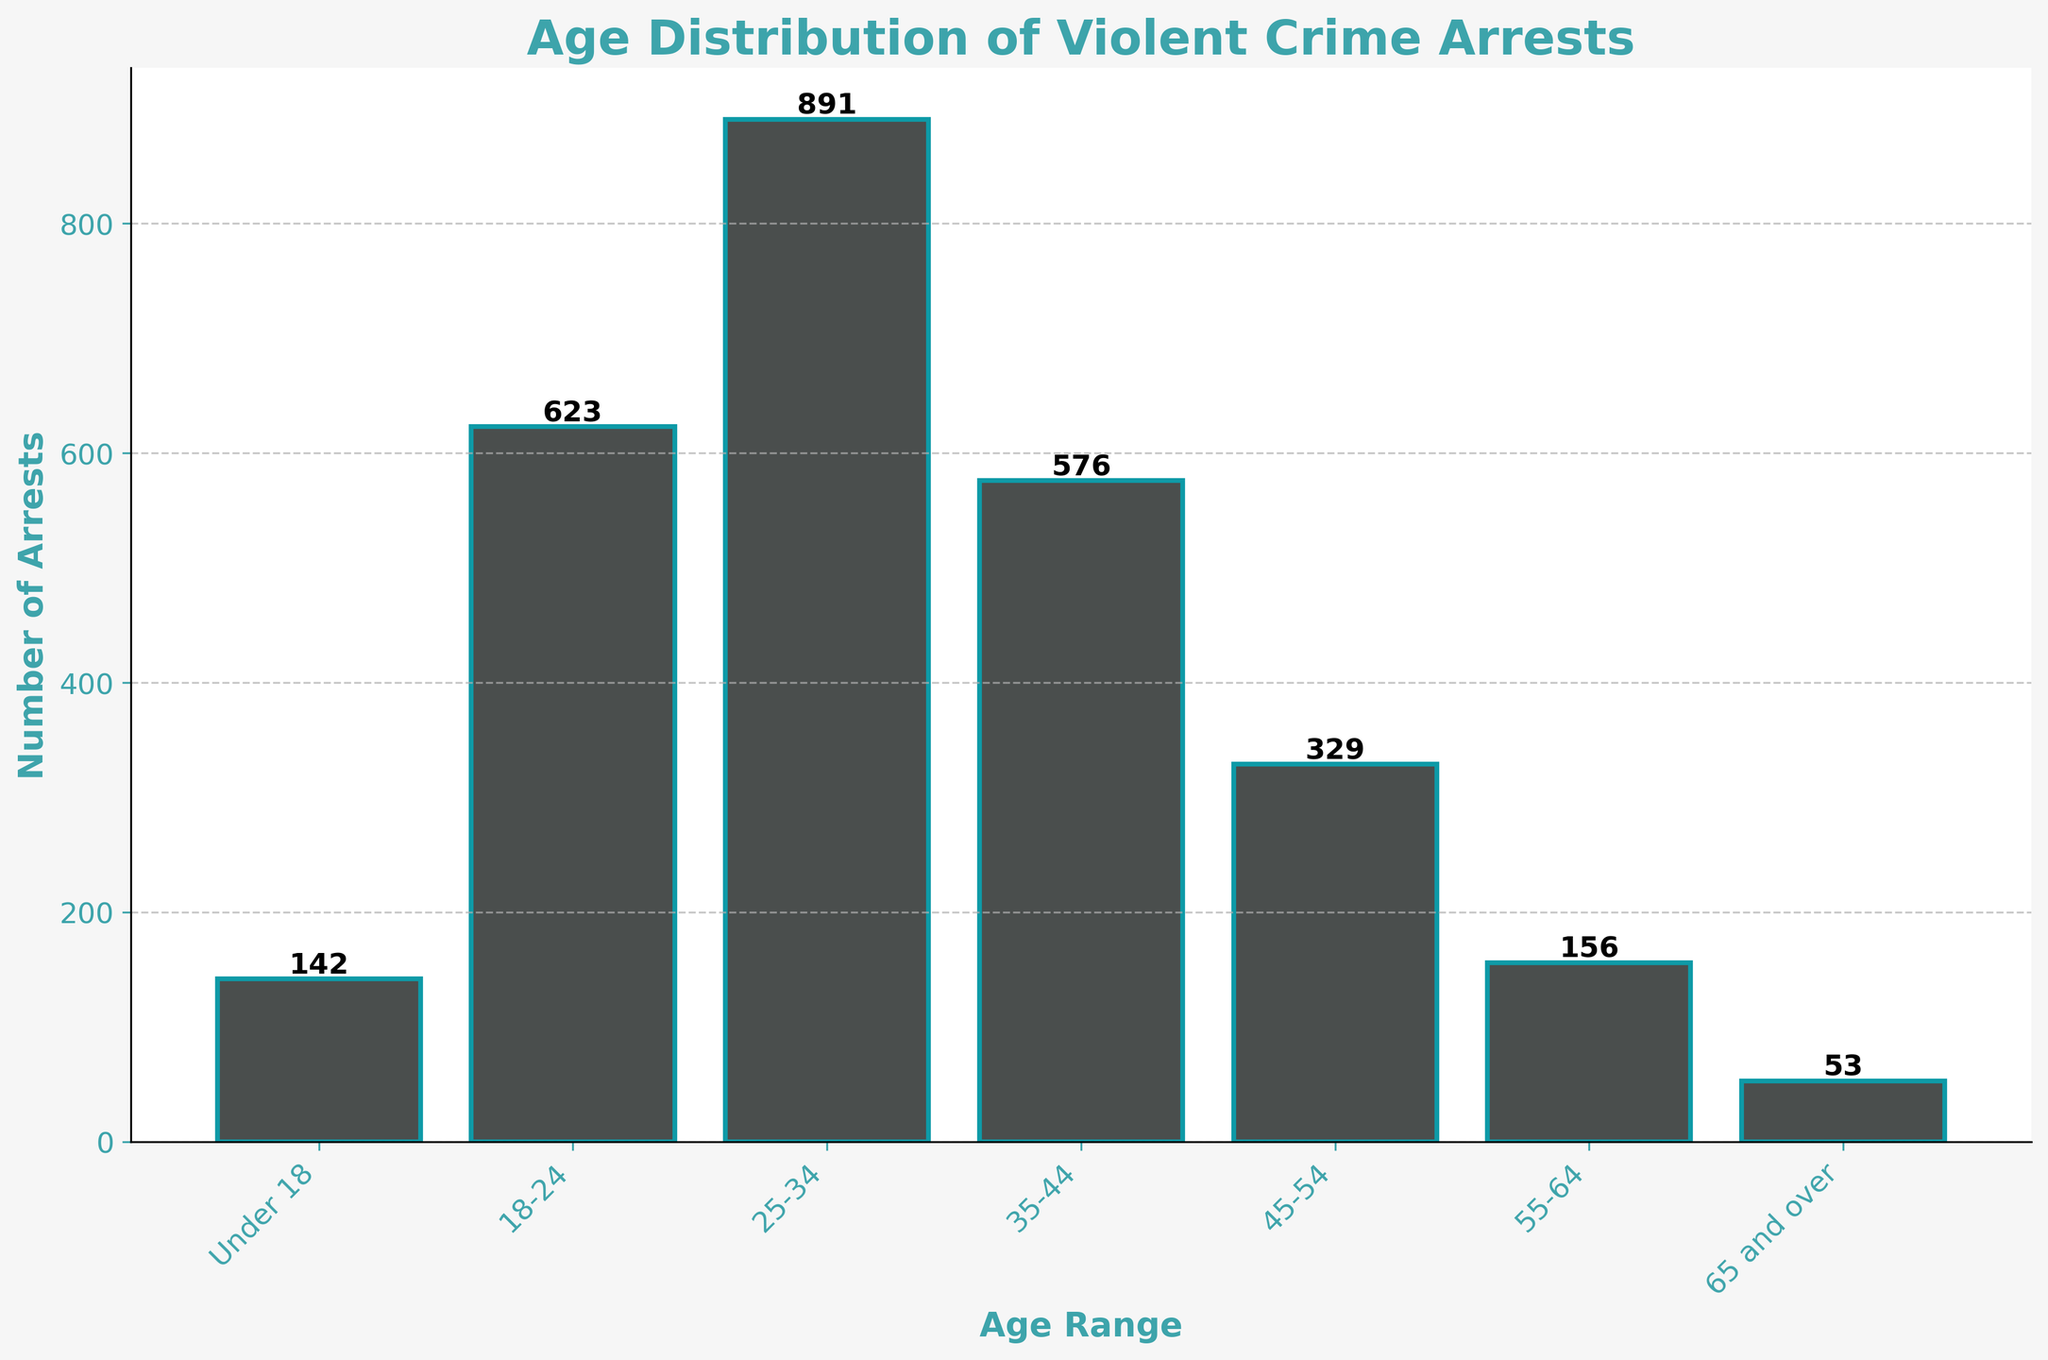What's the title of the plot? The title is located at the top of the plot and is displayed in a prominent font. It helps in understanding what the plot is about.
Answer: Age Distribution of Violent Crime Arrests What is the age range with the highest number of arrests? By comparing the height of the bars for each age range, we can identify the one with the highest bar, indicating the greatest number of arrests.
Answer: 25-34 How many arrests were made for individuals under 18? Locate the bar corresponding to the "Under 18" age range and read the value label on top of the bar.
Answer: 142 Which age range has more arrests: 35-44 or 45-54? Compare the height of the bars for the two age ranges provided. The taller bar represents the age range with more arrests.
Answer: 35-44 What is the total number of arrests for individuals aged 35-44 and 45-54 combined? Add the number of arrests for the 35-44 age range to the number of arrests for the 45-54 age range.
Answer: 905 Which age range has the least number of arrests? Identify the shortest bar on the histogram to find the age range with the least number of arrests.
Answer: 65 and over How many fewer arrests were there for individuals aged 55-64 compared to those aged 25-34? Subtract the number of arrests for the 55-64 age range from the number of arrests for the 25-34 age range.
Answer: 735 What is the total number of arrests across all age ranges? Sum the number of arrests for all age ranges to get the total number.
Answer: 2,770 Which two age ranges have a similar number of arrests? Visually inspect the bars to find two that have nearly the same height and check their value labels.
Answer: Under 18 and 65 and over What's the average number of arrests per age range? Divide the total number of arrests by the number of age ranges provided.
Answer: 396 